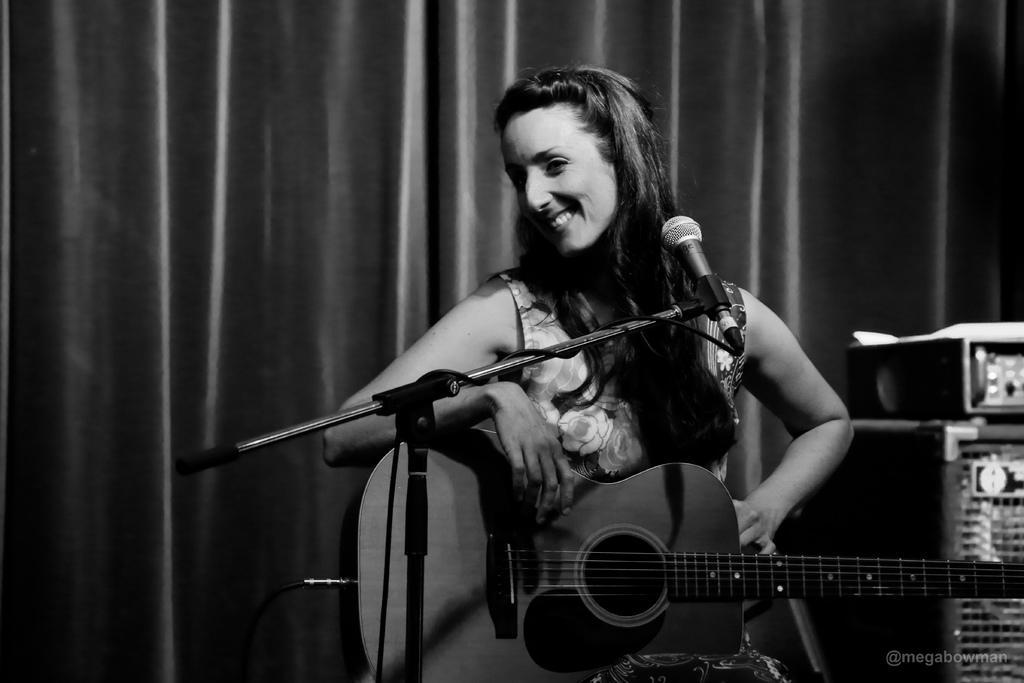Describe this image in one or two sentences. In this image, In the middle there is a woman holding a music instrument which is in yellow color, In the right side there are some music instruments and in the background there is a white color curtain. 